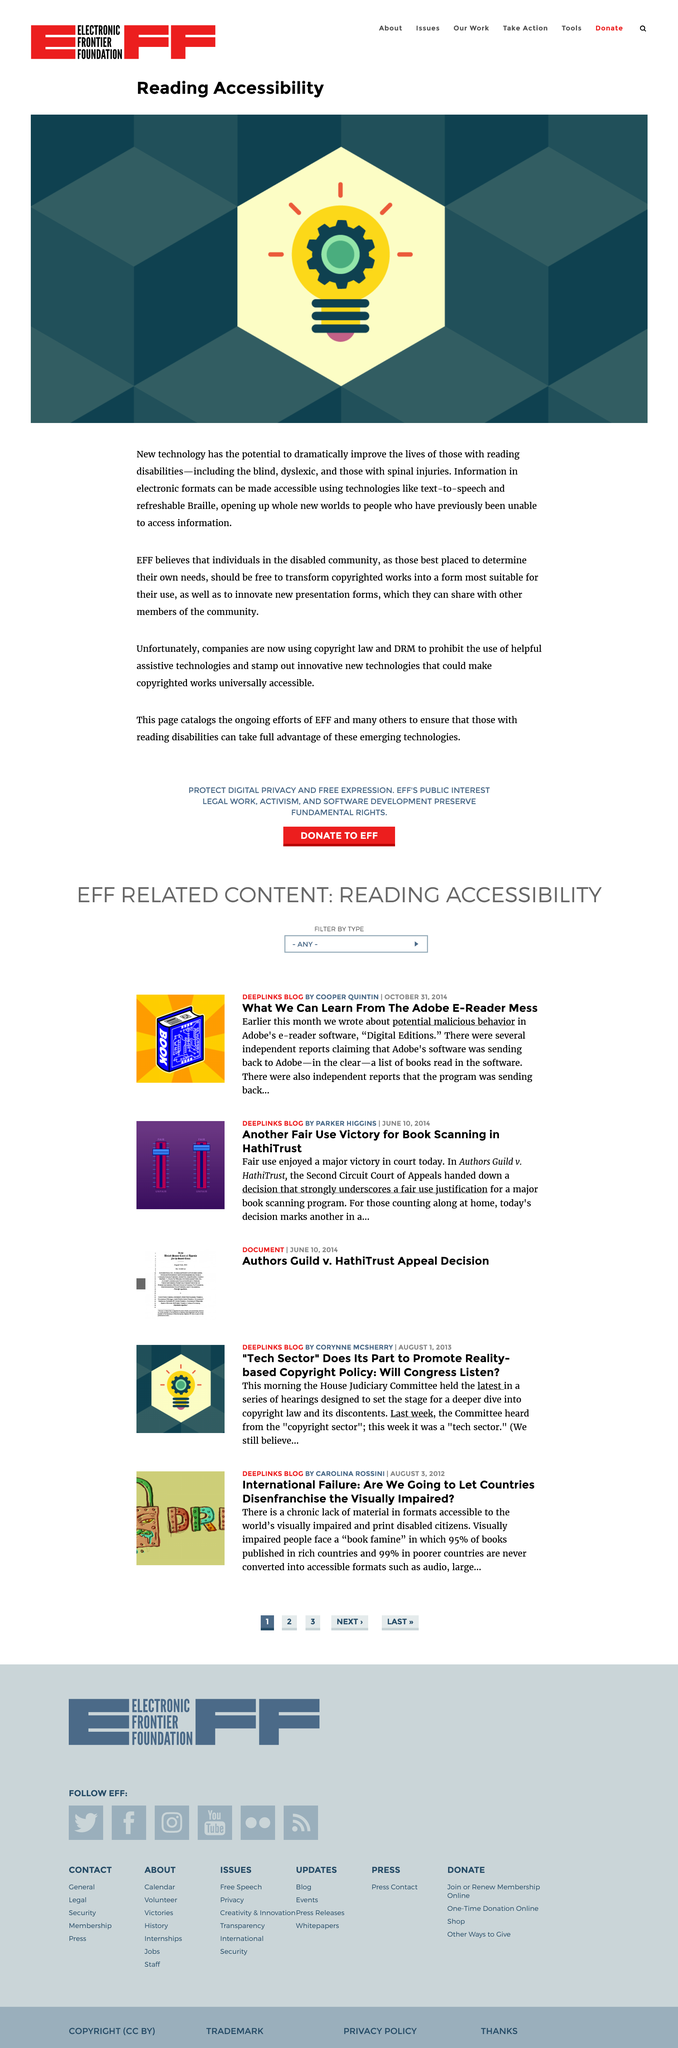Draw attention to some important aspects in this diagram. The development of new technology has the potential to significantly improve the lives of individuals with reading disabilities by providing them with greater accessibility and opportunities to overcome their challenges. Two examples of electronic formats that can improve reading accessibility for individuals with reading disabilities are text-to-speech and refreshable braille technologies. These technologies allow individuals with reading disabilities to access information in electronic formats in a more accessible and convenient way. Reading disabilities encompass a range of conditions that impair an individual's ability to read and comprehend written text, including but not limited to blindness, dyslexia, and spinal injuries. 